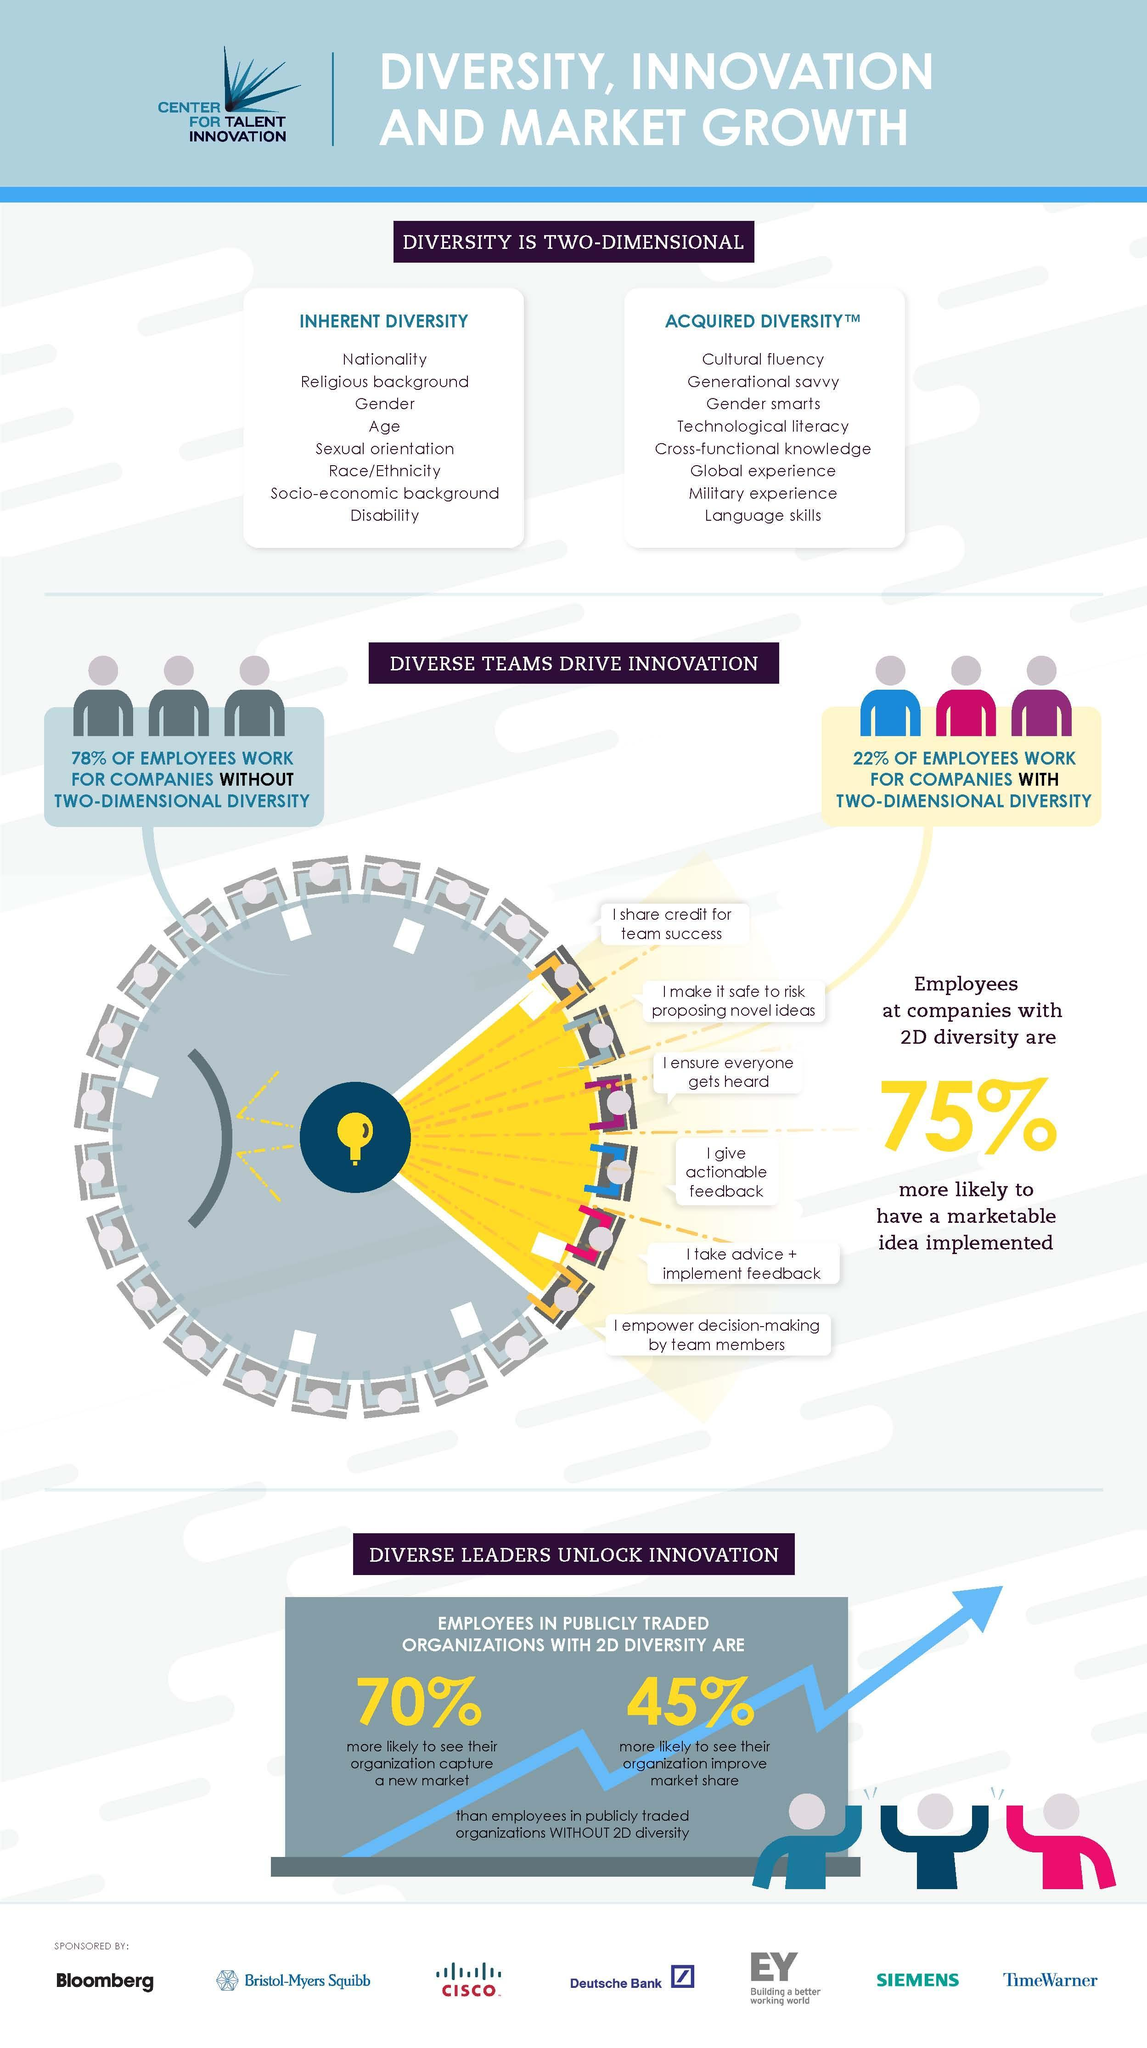What are the two dimensions of diversity given in this infographic?
Answer the question with a short phrase. inherent diversity, acquired diversity who is more likely to have a marketable idea implemented? employees at companies with 2D diversity Which companies are more innovative - company with 2D diversity or company without 2d diversity? company with 2D diversity What are the last three items given under the heading acquired diversity? global experience, military experience, language skills What are the three top items given under the heading inherent diversity? nationality, religious background, gender 